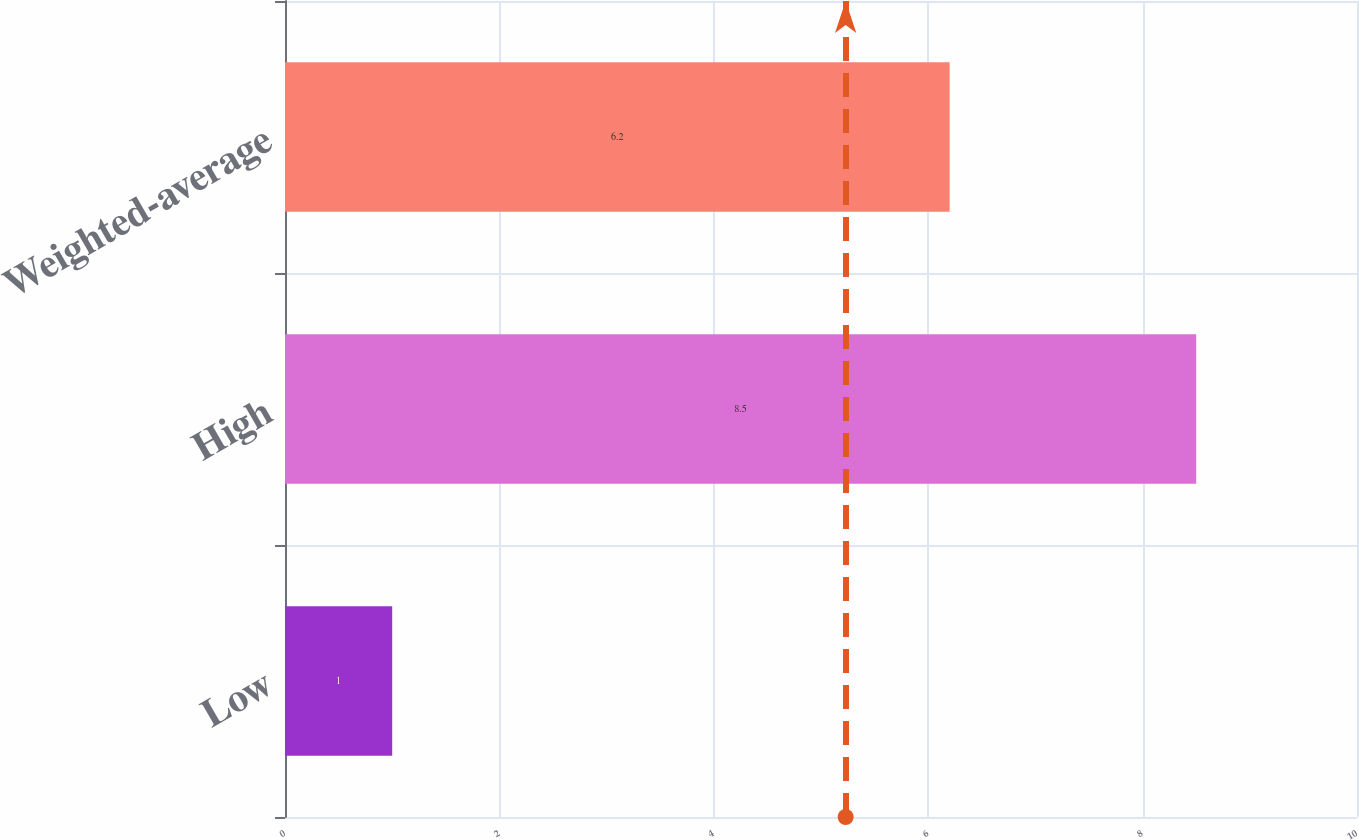<chart> <loc_0><loc_0><loc_500><loc_500><bar_chart><fcel>Low<fcel>High<fcel>Weighted-average<nl><fcel>1<fcel>8.5<fcel>6.2<nl></chart> 